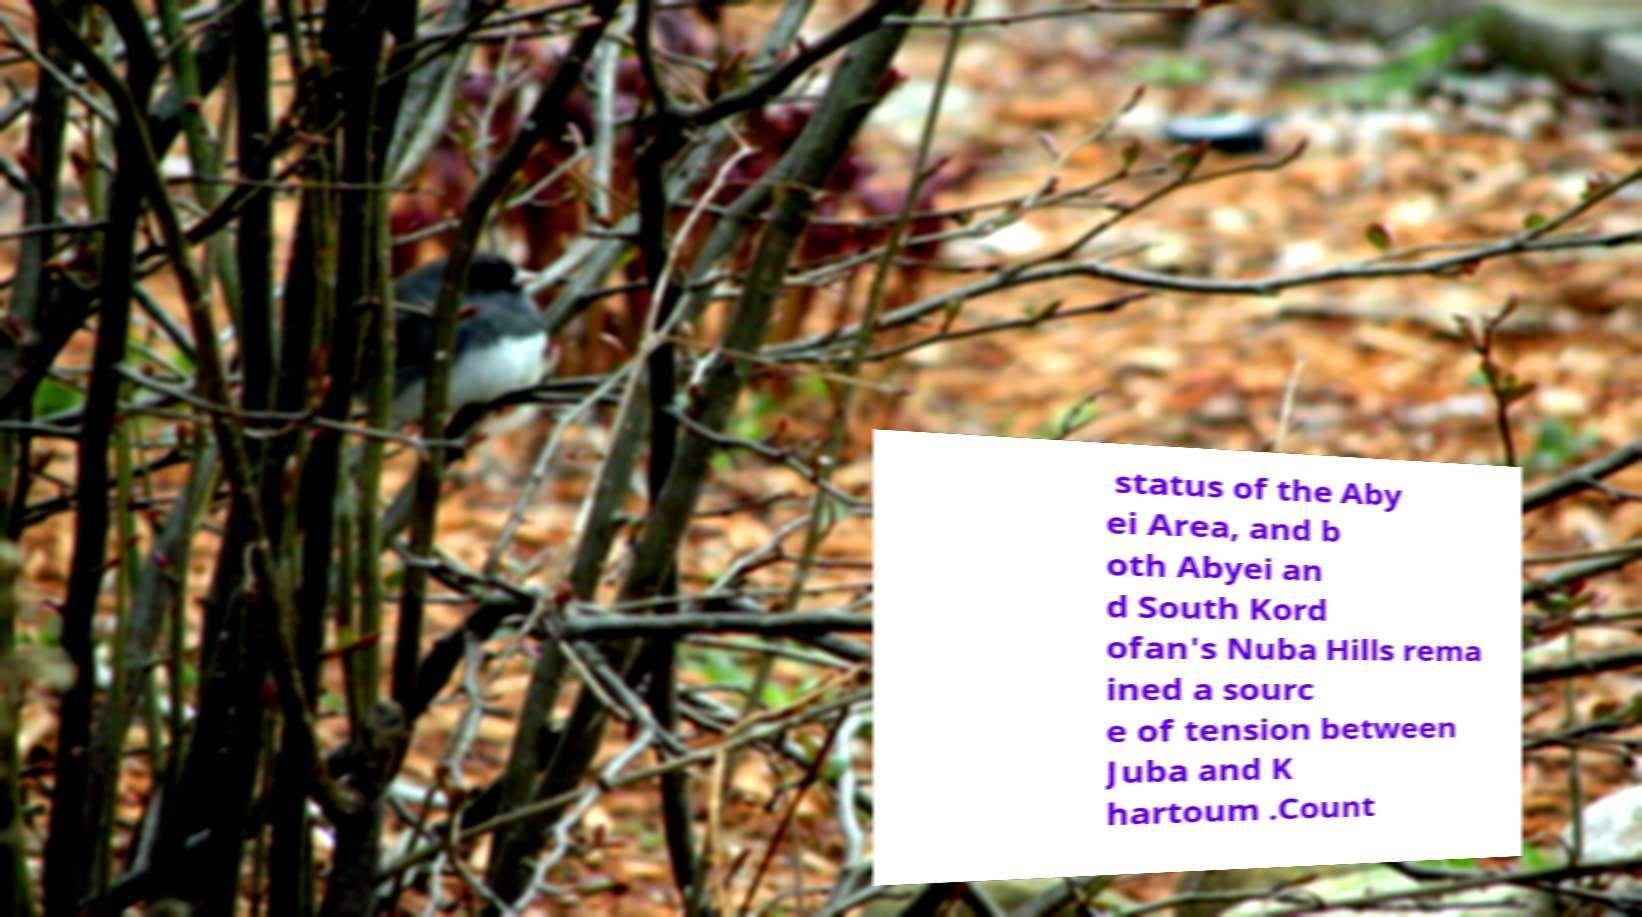There's text embedded in this image that I need extracted. Can you transcribe it verbatim? status of the Aby ei Area, and b oth Abyei an d South Kord ofan's Nuba Hills rema ined a sourc e of tension between Juba and K hartoum .Count 